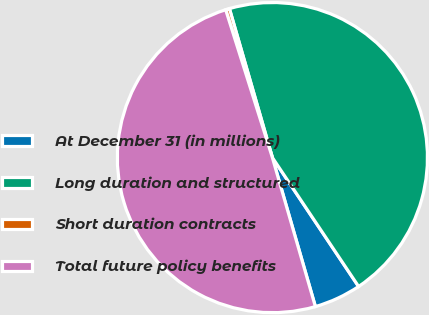Convert chart to OTSL. <chart><loc_0><loc_0><loc_500><loc_500><pie_chart><fcel>At December 31 (in millions)<fcel>Long duration and structured<fcel>Short duration contracts<fcel>Total future policy benefits<nl><fcel>4.91%<fcel>45.09%<fcel>0.4%<fcel>49.6%<nl></chart> 